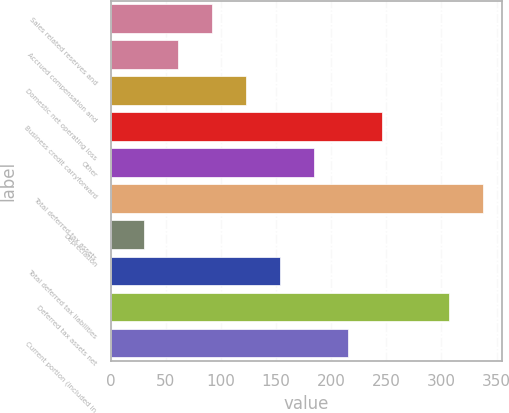Convert chart to OTSL. <chart><loc_0><loc_0><loc_500><loc_500><bar_chart><fcel>Sales related reserves and<fcel>Accrued compensation and<fcel>Domestic net operating loss<fcel>Business credit carryforward<fcel>Other<fcel>Total deferred tax assets<fcel>Depreciation<fcel>Total deferred tax liabilities<fcel>Deferred tax assets net<fcel>Current portion (included in<nl><fcel>91.6<fcel>60.8<fcel>122.4<fcel>245.6<fcel>184<fcel>338<fcel>30<fcel>153.2<fcel>307.2<fcel>214.8<nl></chart> 